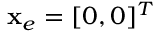<formula> <loc_0><loc_0><loc_500><loc_500>x _ { e } = [ 0 , 0 ] ^ { T }</formula> 